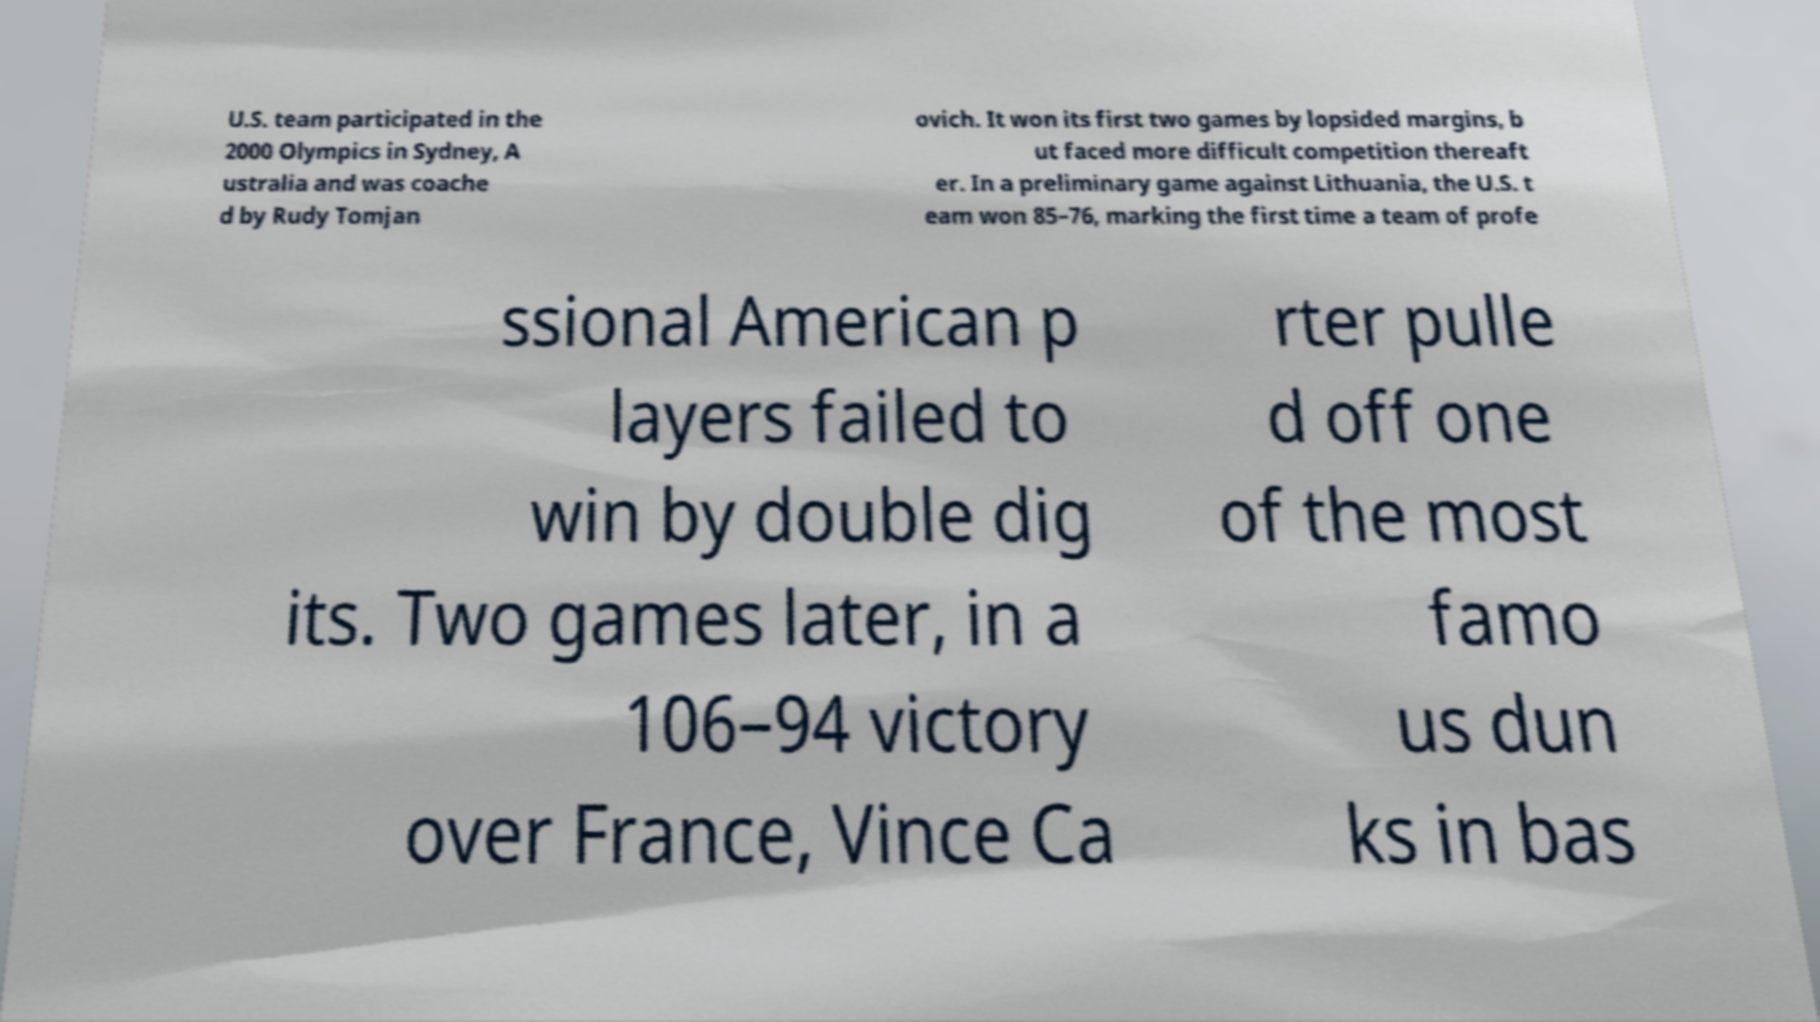Can you read and provide the text displayed in the image?This photo seems to have some interesting text. Can you extract and type it out for me? U.S. team participated in the 2000 Olympics in Sydney, A ustralia and was coache d by Rudy Tomjan ovich. It won its first two games by lopsided margins, b ut faced more difficult competition thereaft er. In a preliminary game against Lithuania, the U.S. t eam won 85–76, marking the first time a team of profe ssional American p layers failed to win by double dig its. Two games later, in a 106–94 victory over France, Vince Ca rter pulle d off one of the most famo us dun ks in bas 